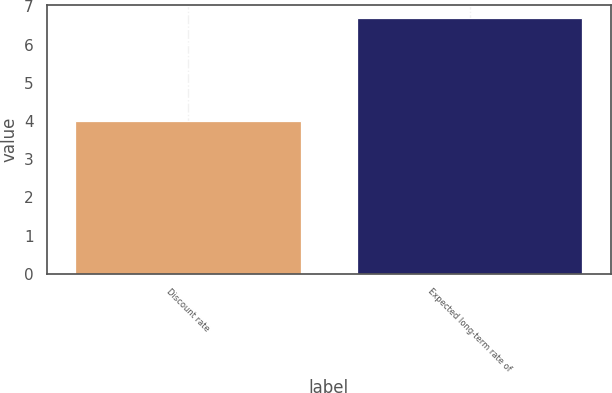Convert chart. <chart><loc_0><loc_0><loc_500><loc_500><bar_chart><fcel>Discount rate<fcel>Expected long-term rate of<nl><fcel>4<fcel>6.7<nl></chart> 